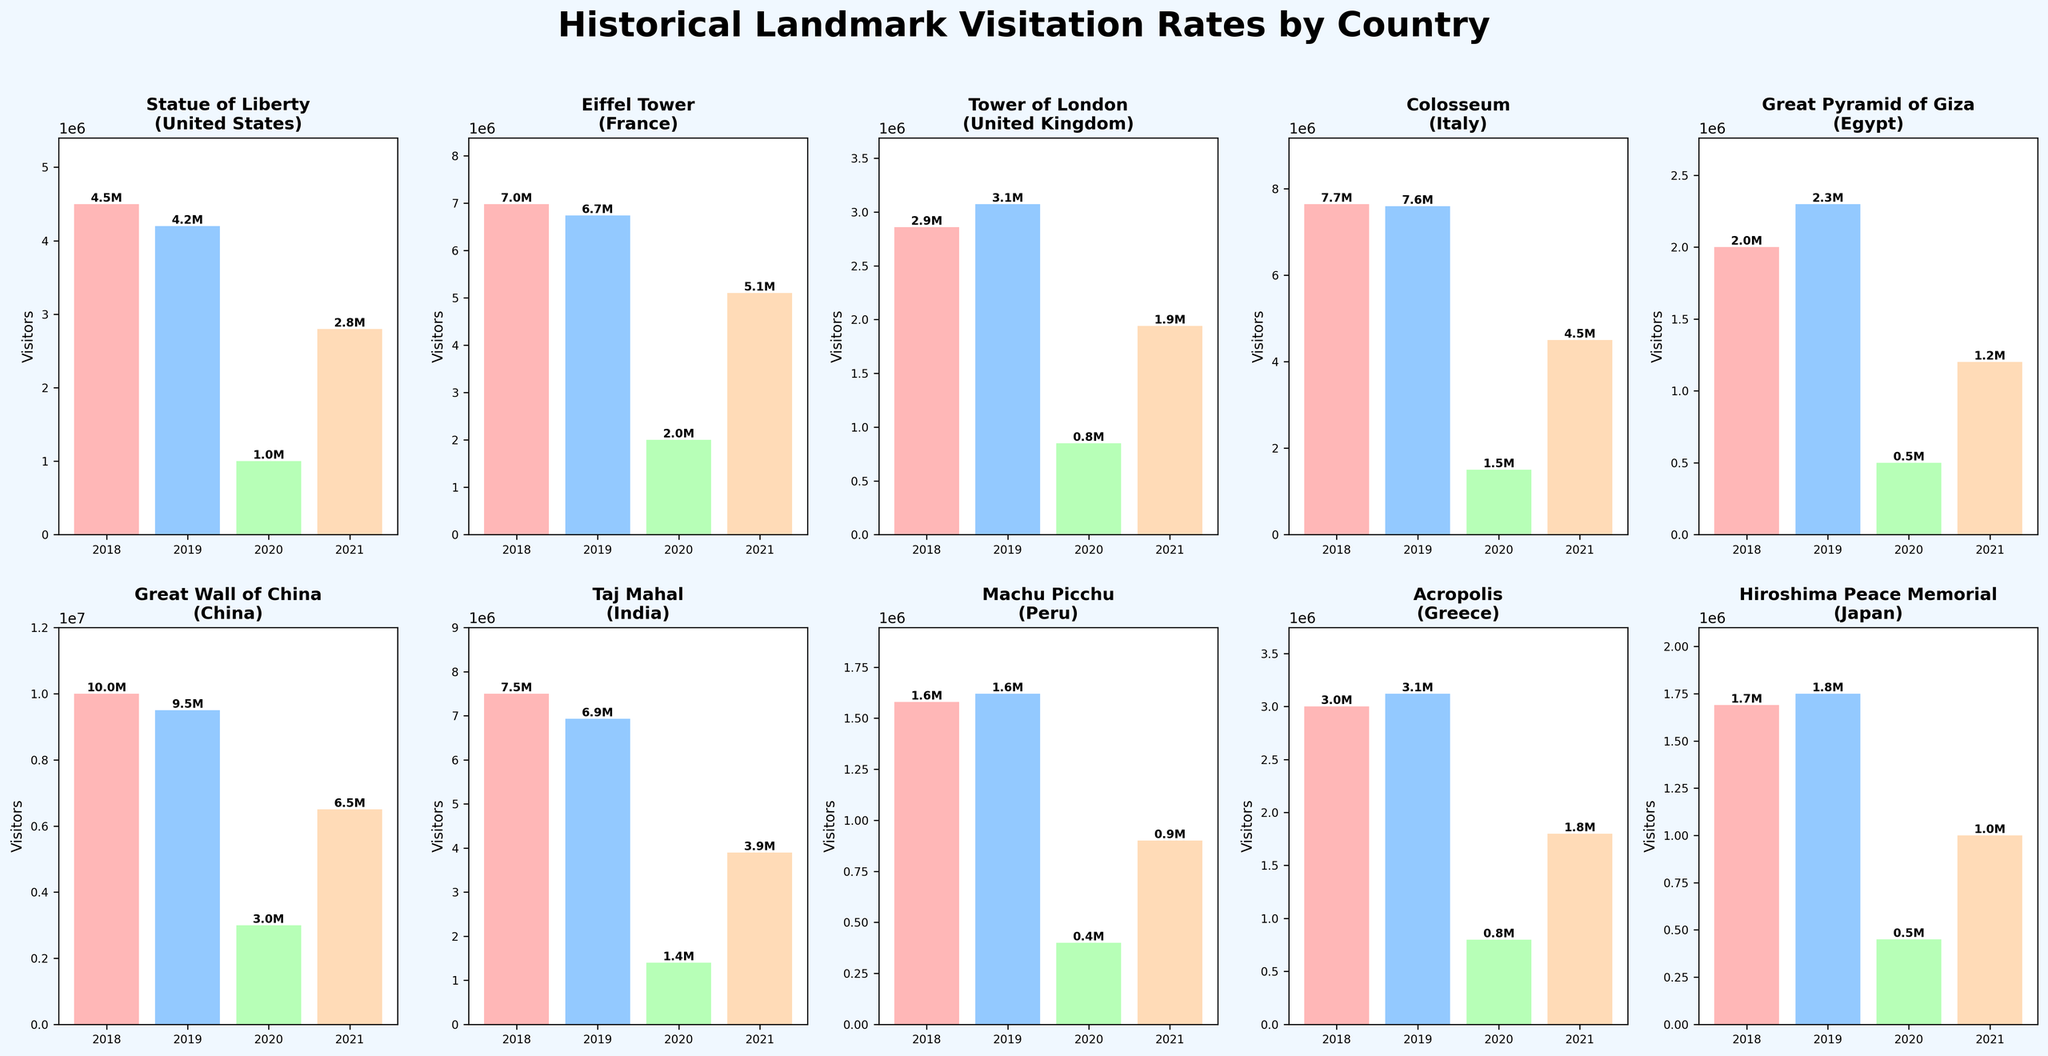what is the title of the figure? The title is displayed at the top of the figure. It combines information about the subject of the data (historical landmark visits) and the segmentation by country. The title reads "Historical Landmark Visitation Rates by Country."
Answer: "Historical Landmark Visitation Rates by Country" how many subplots are in the figure? The figure has a grid layout with 2 rows and 5 columns, resulting in a total of 2*5 = 10 subplots.
Answer: 10 which year had the highest number of visitors for the Eiffel Tower in France? By looking at the Eiffel Tower subplot, the 2018 bar is the tallest among the four bars representing the years.
Answer: 2018 what is the color used for the visitor data of 2018? The bar representing visitor data of 2018 has a unique color. In this figure, it is a reddish-pink shade.
Answer: reddish-pink what is the average number of visitors to the Great Wall of China from 2018 to 2021? The subplot for the Great Wall of China shows visitor numbers for each year: 10,000,000 in 2018, 9,500,000 in 2019, 3,000,000 in 2020, and 6,500,000 in 2021. Summing these up gives 29,000,000, and dividing by 4 gives the average of 29,000,000 / 4 = 7,250,000.
Answer: 7,250,000 which landmark had the least number of visitors in 2020? By examining the 2020 bars across all subplots, the Hiroshima Peace Memorial has the shortest bar, indicating the fewest visitors in 2020.
Answer: Hiroshima Peace Memorial how did the visitor numbers to Machu Picchu change from 2019 to 2021? For Machu Picchu, the visitor numbers change as follows: 1,620,000 in 2019, 400,000 in 2020, and 900,000 in 2021. The numbers dropped sharply from 2019 to 2020 and then increased from 2020 to 2021.
Answer: Sharp drop, then an increase which landmarks had more than 2,000,000 visitors in 2021? Checking the y-axis values for 2021 across all subplots reveals that the Statue of Liberty, Eiffel Tower, Colosseum, and Great Wall of China had more than 2,000,000 visitors in 2021.
Answer: Statue of Liberty, Eiffel Tower, Colosseum, Great Wall of China what is the sum of visitors to the Taj Mahal across all years? The Taj Mahal subplot shows visitor numbers: 7,500,000 in 2018, 6,930,000 in 2019, 1,400,000 in 2020, and 3,900,000 in 2021. Adding these up gives  7,500,000 + 6,930,000 + 1,400,000 + 3,900,000 = 19,730,000.
Answer: 19,730,000 